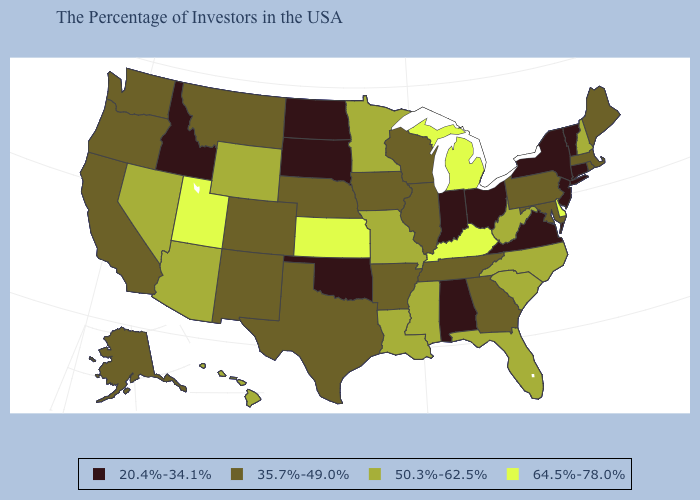Name the states that have a value in the range 20.4%-34.1%?
Concise answer only. Vermont, Connecticut, New York, New Jersey, Virginia, Ohio, Indiana, Alabama, Oklahoma, South Dakota, North Dakota, Idaho. What is the highest value in the West ?
Write a very short answer. 64.5%-78.0%. Does Rhode Island have the same value as California?
Be succinct. Yes. What is the highest value in the South ?
Concise answer only. 64.5%-78.0%. What is the lowest value in the Northeast?
Give a very brief answer. 20.4%-34.1%. Does Idaho have a lower value than Alaska?
Keep it brief. Yes. Does Massachusetts have a higher value than Idaho?
Be succinct. Yes. Does Colorado have a lower value than Delaware?
Be succinct. Yes. Among the states that border Illinois , which have the highest value?
Give a very brief answer. Kentucky. Does Alaska have the same value as Washington?
Keep it brief. Yes. What is the lowest value in states that border Ohio?
Write a very short answer. 20.4%-34.1%. Among the states that border Arkansas , which have the lowest value?
Quick response, please. Oklahoma. Name the states that have a value in the range 50.3%-62.5%?
Short answer required. New Hampshire, North Carolina, South Carolina, West Virginia, Florida, Mississippi, Louisiana, Missouri, Minnesota, Wyoming, Arizona, Nevada, Hawaii. What is the value of Texas?
Keep it brief. 35.7%-49.0%. Which states have the lowest value in the USA?
Give a very brief answer. Vermont, Connecticut, New York, New Jersey, Virginia, Ohio, Indiana, Alabama, Oklahoma, South Dakota, North Dakota, Idaho. 